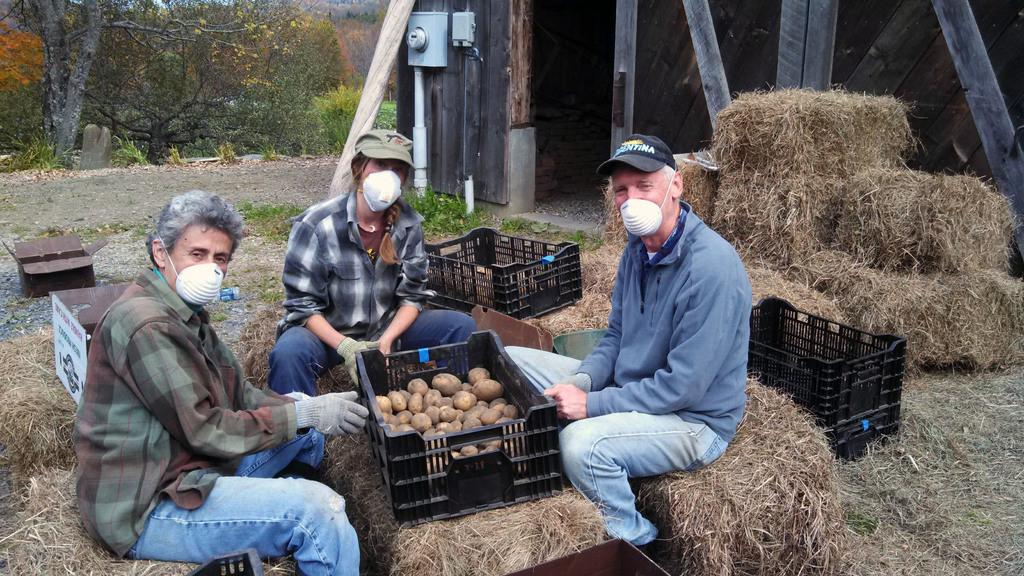What are the people in the image doing? The people in the image are sitting. What objects can be seen in the image besides the people? There are baskets visible in the image. What type of natural environment is present in the image? There is grass visible in the image. What type of structure can be seen in the image? There is a shed in the image. What type of vegetation is present in the image? There are trees in the image. What type of skin condition can be seen on the people in the image? There is no indication of any skin condition on the people in the image. What type of parcel is being delivered in the image? There is no parcel delivery depicted in the image. 